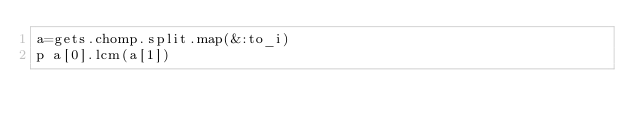Convert code to text. <code><loc_0><loc_0><loc_500><loc_500><_Ruby_>a=gets.chomp.split.map(&:to_i)
p a[0].lcm(a[1])</code> 